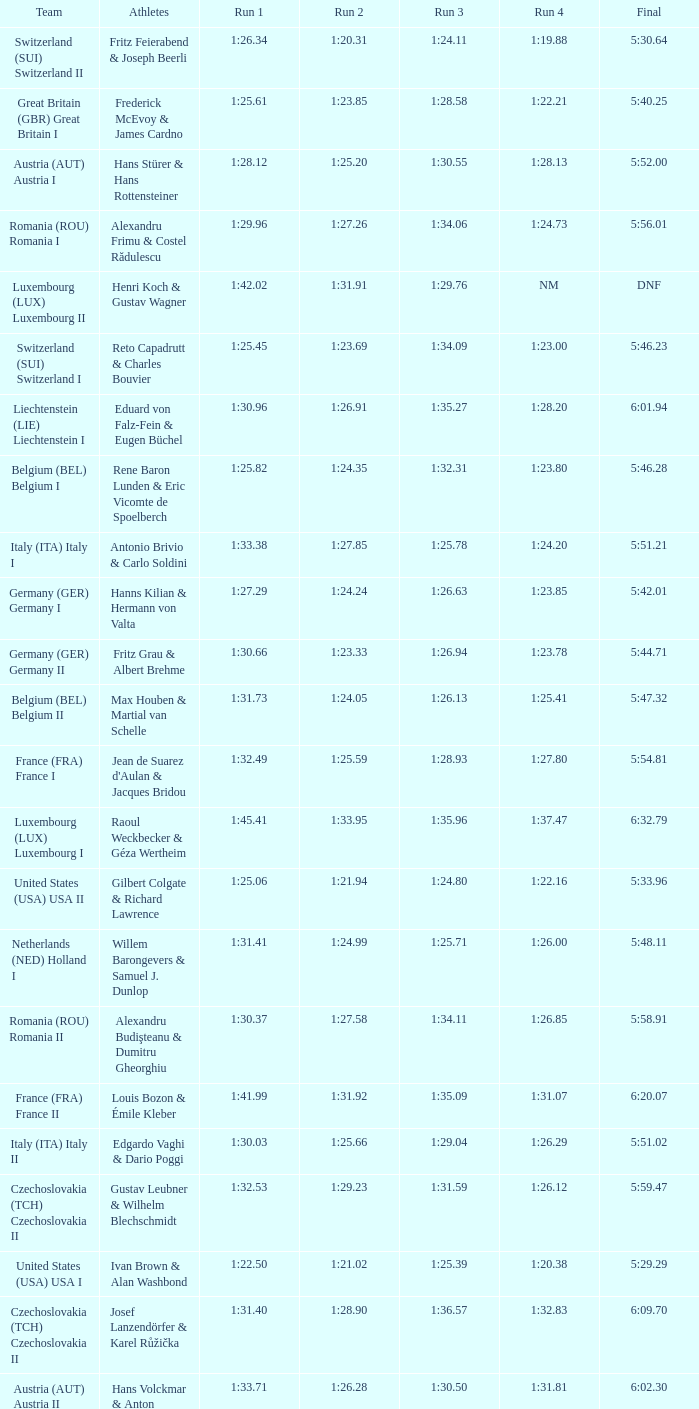Which Final has a Team of liechtenstein (lie) liechtenstein i? 6:01.94. 